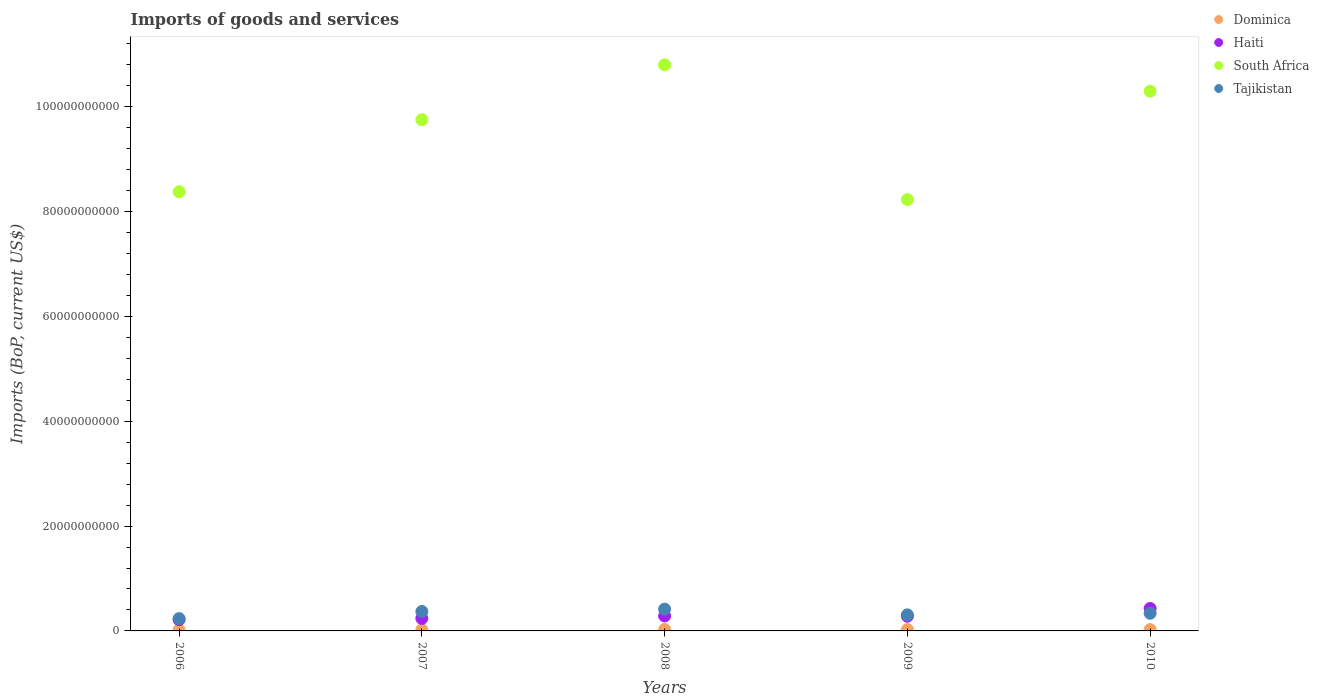What is the amount spent on imports in Haiti in 2006?
Offer a very short reply. 2.14e+09. Across all years, what is the maximum amount spent on imports in South Africa?
Provide a succinct answer. 1.08e+11. Across all years, what is the minimum amount spent on imports in Haiti?
Offer a very short reply. 2.14e+09. In which year was the amount spent on imports in Dominica maximum?
Provide a short and direct response. 2008. In which year was the amount spent on imports in Dominica minimum?
Your answer should be compact. 2006. What is the total amount spent on imports in Tajikistan in the graph?
Your answer should be compact. 1.66e+1. What is the difference between the amount spent on imports in Dominica in 2006 and that in 2009?
Your response must be concise. -6.56e+07. What is the difference between the amount spent on imports in Dominica in 2006 and the amount spent on imports in Haiti in 2007?
Offer a terse response. -2.19e+09. What is the average amount spent on imports in Haiti per year?
Your answer should be very brief. 2.89e+09. In the year 2009, what is the difference between the amount spent on imports in Haiti and amount spent on imports in Tajikistan?
Keep it short and to the point. -2.58e+08. In how many years, is the amount spent on imports in Dominica greater than 28000000000 US$?
Give a very brief answer. 0. What is the ratio of the amount spent on imports in Haiti in 2006 to that in 2007?
Keep it short and to the point. 0.9. Is the amount spent on imports in Dominica in 2006 less than that in 2007?
Your answer should be compact. Yes. What is the difference between the highest and the second highest amount spent on imports in Dominica?
Ensure brevity in your answer.  2.28e+07. What is the difference between the highest and the lowest amount spent on imports in Dominica?
Make the answer very short. 8.85e+07. In how many years, is the amount spent on imports in South Africa greater than the average amount spent on imports in South Africa taken over all years?
Your response must be concise. 3. Is it the case that in every year, the sum of the amount spent on imports in Dominica and amount spent on imports in Haiti  is greater than the sum of amount spent on imports in South Africa and amount spent on imports in Tajikistan?
Give a very brief answer. No. Is it the case that in every year, the sum of the amount spent on imports in Tajikistan and amount spent on imports in Haiti  is greater than the amount spent on imports in Dominica?
Your response must be concise. Yes. Is the amount spent on imports in Dominica strictly less than the amount spent on imports in Haiti over the years?
Offer a terse response. Yes. Does the graph contain any zero values?
Offer a terse response. No. Does the graph contain grids?
Your response must be concise. No. How many legend labels are there?
Make the answer very short. 4. How are the legend labels stacked?
Make the answer very short. Vertical. What is the title of the graph?
Your response must be concise. Imports of goods and services. What is the label or title of the X-axis?
Offer a terse response. Years. What is the label or title of the Y-axis?
Offer a very short reply. Imports (BoP, current US$). What is the Imports (BoP, current US$) in Dominica in 2006?
Make the answer very short. 1.99e+08. What is the Imports (BoP, current US$) in Haiti in 2006?
Give a very brief answer. 2.14e+09. What is the Imports (BoP, current US$) of South Africa in 2006?
Offer a very short reply. 8.38e+1. What is the Imports (BoP, current US$) in Tajikistan in 2006?
Offer a terse response. 2.35e+09. What is the Imports (BoP, current US$) of Dominica in 2007?
Ensure brevity in your answer.  2.36e+08. What is the Imports (BoP, current US$) in Haiti in 2007?
Provide a short and direct response. 2.38e+09. What is the Imports (BoP, current US$) in South Africa in 2007?
Offer a very short reply. 9.75e+1. What is the Imports (BoP, current US$) of Tajikistan in 2007?
Keep it short and to the point. 3.71e+09. What is the Imports (BoP, current US$) in Dominica in 2008?
Your response must be concise. 2.87e+08. What is the Imports (BoP, current US$) of Haiti in 2008?
Provide a succinct answer. 2.85e+09. What is the Imports (BoP, current US$) of South Africa in 2008?
Provide a succinct answer. 1.08e+11. What is the Imports (BoP, current US$) in Tajikistan in 2008?
Give a very brief answer. 4.15e+09. What is the Imports (BoP, current US$) of Dominica in 2009?
Offer a terse response. 2.64e+08. What is the Imports (BoP, current US$) of Haiti in 2009?
Keep it short and to the point. 2.80e+09. What is the Imports (BoP, current US$) in South Africa in 2009?
Your answer should be compact. 8.23e+1. What is the Imports (BoP, current US$) in Tajikistan in 2009?
Offer a very short reply. 3.06e+09. What is the Imports (BoP, current US$) in Dominica in 2010?
Ensure brevity in your answer.  2.65e+08. What is the Imports (BoP, current US$) in Haiti in 2010?
Keep it short and to the point. 4.29e+09. What is the Imports (BoP, current US$) of South Africa in 2010?
Ensure brevity in your answer.  1.03e+11. What is the Imports (BoP, current US$) in Tajikistan in 2010?
Your answer should be compact. 3.36e+09. Across all years, what is the maximum Imports (BoP, current US$) of Dominica?
Keep it short and to the point. 2.87e+08. Across all years, what is the maximum Imports (BoP, current US$) of Haiti?
Provide a succinct answer. 4.29e+09. Across all years, what is the maximum Imports (BoP, current US$) of South Africa?
Offer a very short reply. 1.08e+11. Across all years, what is the maximum Imports (BoP, current US$) of Tajikistan?
Keep it short and to the point. 4.15e+09. Across all years, what is the minimum Imports (BoP, current US$) in Dominica?
Provide a short and direct response. 1.99e+08. Across all years, what is the minimum Imports (BoP, current US$) in Haiti?
Your answer should be compact. 2.14e+09. Across all years, what is the minimum Imports (BoP, current US$) in South Africa?
Provide a short and direct response. 8.23e+1. Across all years, what is the minimum Imports (BoP, current US$) of Tajikistan?
Ensure brevity in your answer.  2.35e+09. What is the total Imports (BoP, current US$) in Dominica in the graph?
Your answer should be compact. 1.25e+09. What is the total Imports (BoP, current US$) in Haiti in the graph?
Your answer should be compact. 1.45e+1. What is the total Imports (BoP, current US$) in South Africa in the graph?
Offer a very short reply. 4.74e+11. What is the total Imports (BoP, current US$) of Tajikistan in the graph?
Offer a very short reply. 1.66e+1. What is the difference between the Imports (BoP, current US$) of Dominica in 2006 and that in 2007?
Give a very brief answer. -3.75e+07. What is the difference between the Imports (BoP, current US$) in Haiti in 2006 and that in 2007?
Your answer should be compact. -2.43e+08. What is the difference between the Imports (BoP, current US$) in South Africa in 2006 and that in 2007?
Give a very brief answer. -1.37e+1. What is the difference between the Imports (BoP, current US$) of Tajikistan in 2006 and that in 2007?
Give a very brief answer. -1.36e+09. What is the difference between the Imports (BoP, current US$) of Dominica in 2006 and that in 2008?
Make the answer very short. -8.85e+07. What is the difference between the Imports (BoP, current US$) of Haiti in 2006 and that in 2008?
Your answer should be very brief. -7.12e+08. What is the difference between the Imports (BoP, current US$) of South Africa in 2006 and that in 2008?
Make the answer very short. -2.42e+1. What is the difference between the Imports (BoP, current US$) in Tajikistan in 2006 and that in 2008?
Keep it short and to the point. -1.81e+09. What is the difference between the Imports (BoP, current US$) in Dominica in 2006 and that in 2009?
Give a very brief answer. -6.56e+07. What is the difference between the Imports (BoP, current US$) in Haiti in 2006 and that in 2009?
Make the answer very short. -6.63e+08. What is the difference between the Imports (BoP, current US$) of South Africa in 2006 and that in 2009?
Provide a short and direct response. 1.49e+09. What is the difference between the Imports (BoP, current US$) of Tajikistan in 2006 and that in 2009?
Make the answer very short. -7.13e+08. What is the difference between the Imports (BoP, current US$) of Dominica in 2006 and that in 2010?
Offer a terse response. -6.57e+07. What is the difference between the Imports (BoP, current US$) in Haiti in 2006 and that in 2010?
Your answer should be compact. -2.15e+09. What is the difference between the Imports (BoP, current US$) of South Africa in 2006 and that in 2010?
Offer a terse response. -1.92e+1. What is the difference between the Imports (BoP, current US$) in Tajikistan in 2006 and that in 2010?
Give a very brief answer. -1.02e+09. What is the difference between the Imports (BoP, current US$) of Dominica in 2007 and that in 2008?
Provide a succinct answer. -5.10e+07. What is the difference between the Imports (BoP, current US$) of Haiti in 2007 and that in 2008?
Provide a short and direct response. -4.69e+08. What is the difference between the Imports (BoP, current US$) in South Africa in 2007 and that in 2008?
Provide a succinct answer. -1.05e+1. What is the difference between the Imports (BoP, current US$) of Tajikistan in 2007 and that in 2008?
Your response must be concise. -4.47e+08. What is the difference between the Imports (BoP, current US$) in Dominica in 2007 and that in 2009?
Offer a very short reply. -2.81e+07. What is the difference between the Imports (BoP, current US$) in Haiti in 2007 and that in 2009?
Make the answer very short. -4.20e+08. What is the difference between the Imports (BoP, current US$) of South Africa in 2007 and that in 2009?
Offer a very short reply. 1.52e+1. What is the difference between the Imports (BoP, current US$) of Tajikistan in 2007 and that in 2009?
Provide a short and direct response. 6.45e+08. What is the difference between the Imports (BoP, current US$) of Dominica in 2007 and that in 2010?
Your response must be concise. -2.82e+07. What is the difference between the Imports (BoP, current US$) of Haiti in 2007 and that in 2010?
Offer a very short reply. -1.90e+09. What is the difference between the Imports (BoP, current US$) of South Africa in 2007 and that in 2010?
Offer a very short reply. -5.45e+09. What is the difference between the Imports (BoP, current US$) in Tajikistan in 2007 and that in 2010?
Your answer should be very brief. 3.43e+08. What is the difference between the Imports (BoP, current US$) in Dominica in 2008 and that in 2009?
Provide a short and direct response. 2.29e+07. What is the difference between the Imports (BoP, current US$) in Haiti in 2008 and that in 2009?
Give a very brief answer. 4.96e+07. What is the difference between the Imports (BoP, current US$) in South Africa in 2008 and that in 2009?
Offer a very short reply. 2.57e+1. What is the difference between the Imports (BoP, current US$) in Tajikistan in 2008 and that in 2009?
Your answer should be compact. 1.09e+09. What is the difference between the Imports (BoP, current US$) of Dominica in 2008 and that in 2010?
Offer a terse response. 2.28e+07. What is the difference between the Imports (BoP, current US$) in Haiti in 2008 and that in 2010?
Offer a very short reply. -1.43e+09. What is the difference between the Imports (BoP, current US$) in South Africa in 2008 and that in 2010?
Give a very brief answer. 5.02e+09. What is the difference between the Imports (BoP, current US$) of Tajikistan in 2008 and that in 2010?
Give a very brief answer. 7.90e+08. What is the difference between the Imports (BoP, current US$) of Dominica in 2009 and that in 2010?
Your answer should be very brief. -5.28e+04. What is the difference between the Imports (BoP, current US$) in Haiti in 2009 and that in 2010?
Your response must be concise. -1.48e+09. What is the difference between the Imports (BoP, current US$) in South Africa in 2009 and that in 2010?
Provide a succinct answer. -2.07e+1. What is the difference between the Imports (BoP, current US$) in Tajikistan in 2009 and that in 2010?
Your answer should be very brief. -3.02e+08. What is the difference between the Imports (BoP, current US$) in Dominica in 2006 and the Imports (BoP, current US$) in Haiti in 2007?
Offer a terse response. -2.19e+09. What is the difference between the Imports (BoP, current US$) in Dominica in 2006 and the Imports (BoP, current US$) in South Africa in 2007?
Provide a succinct answer. -9.73e+1. What is the difference between the Imports (BoP, current US$) of Dominica in 2006 and the Imports (BoP, current US$) of Tajikistan in 2007?
Make the answer very short. -3.51e+09. What is the difference between the Imports (BoP, current US$) in Haiti in 2006 and the Imports (BoP, current US$) in South Africa in 2007?
Your answer should be very brief. -9.54e+1. What is the difference between the Imports (BoP, current US$) of Haiti in 2006 and the Imports (BoP, current US$) of Tajikistan in 2007?
Keep it short and to the point. -1.57e+09. What is the difference between the Imports (BoP, current US$) of South Africa in 2006 and the Imports (BoP, current US$) of Tajikistan in 2007?
Your response must be concise. 8.01e+1. What is the difference between the Imports (BoP, current US$) of Dominica in 2006 and the Imports (BoP, current US$) of Haiti in 2008?
Offer a very short reply. -2.65e+09. What is the difference between the Imports (BoP, current US$) in Dominica in 2006 and the Imports (BoP, current US$) in South Africa in 2008?
Give a very brief answer. -1.08e+11. What is the difference between the Imports (BoP, current US$) in Dominica in 2006 and the Imports (BoP, current US$) in Tajikistan in 2008?
Your answer should be very brief. -3.96e+09. What is the difference between the Imports (BoP, current US$) of Haiti in 2006 and the Imports (BoP, current US$) of South Africa in 2008?
Ensure brevity in your answer.  -1.06e+11. What is the difference between the Imports (BoP, current US$) in Haiti in 2006 and the Imports (BoP, current US$) in Tajikistan in 2008?
Ensure brevity in your answer.  -2.01e+09. What is the difference between the Imports (BoP, current US$) of South Africa in 2006 and the Imports (BoP, current US$) of Tajikistan in 2008?
Provide a short and direct response. 7.96e+1. What is the difference between the Imports (BoP, current US$) in Dominica in 2006 and the Imports (BoP, current US$) in Haiti in 2009?
Make the answer very short. -2.61e+09. What is the difference between the Imports (BoP, current US$) in Dominica in 2006 and the Imports (BoP, current US$) in South Africa in 2009?
Make the answer very short. -8.21e+1. What is the difference between the Imports (BoP, current US$) in Dominica in 2006 and the Imports (BoP, current US$) in Tajikistan in 2009?
Keep it short and to the point. -2.86e+09. What is the difference between the Imports (BoP, current US$) of Haiti in 2006 and the Imports (BoP, current US$) of South Africa in 2009?
Ensure brevity in your answer.  -8.01e+1. What is the difference between the Imports (BoP, current US$) of Haiti in 2006 and the Imports (BoP, current US$) of Tajikistan in 2009?
Your answer should be compact. -9.21e+08. What is the difference between the Imports (BoP, current US$) in South Africa in 2006 and the Imports (BoP, current US$) in Tajikistan in 2009?
Offer a very short reply. 8.07e+1. What is the difference between the Imports (BoP, current US$) in Dominica in 2006 and the Imports (BoP, current US$) in Haiti in 2010?
Offer a terse response. -4.09e+09. What is the difference between the Imports (BoP, current US$) in Dominica in 2006 and the Imports (BoP, current US$) in South Africa in 2010?
Your answer should be compact. -1.03e+11. What is the difference between the Imports (BoP, current US$) of Dominica in 2006 and the Imports (BoP, current US$) of Tajikistan in 2010?
Offer a very short reply. -3.17e+09. What is the difference between the Imports (BoP, current US$) of Haiti in 2006 and the Imports (BoP, current US$) of South Africa in 2010?
Offer a terse response. -1.01e+11. What is the difference between the Imports (BoP, current US$) of Haiti in 2006 and the Imports (BoP, current US$) of Tajikistan in 2010?
Offer a very short reply. -1.22e+09. What is the difference between the Imports (BoP, current US$) of South Africa in 2006 and the Imports (BoP, current US$) of Tajikistan in 2010?
Keep it short and to the point. 8.04e+1. What is the difference between the Imports (BoP, current US$) in Dominica in 2007 and the Imports (BoP, current US$) in Haiti in 2008?
Your response must be concise. -2.62e+09. What is the difference between the Imports (BoP, current US$) of Dominica in 2007 and the Imports (BoP, current US$) of South Africa in 2008?
Offer a terse response. -1.08e+11. What is the difference between the Imports (BoP, current US$) in Dominica in 2007 and the Imports (BoP, current US$) in Tajikistan in 2008?
Your response must be concise. -3.92e+09. What is the difference between the Imports (BoP, current US$) of Haiti in 2007 and the Imports (BoP, current US$) of South Africa in 2008?
Provide a succinct answer. -1.06e+11. What is the difference between the Imports (BoP, current US$) in Haiti in 2007 and the Imports (BoP, current US$) in Tajikistan in 2008?
Keep it short and to the point. -1.77e+09. What is the difference between the Imports (BoP, current US$) of South Africa in 2007 and the Imports (BoP, current US$) of Tajikistan in 2008?
Provide a short and direct response. 9.34e+1. What is the difference between the Imports (BoP, current US$) in Dominica in 2007 and the Imports (BoP, current US$) in Haiti in 2009?
Your answer should be very brief. -2.57e+09. What is the difference between the Imports (BoP, current US$) of Dominica in 2007 and the Imports (BoP, current US$) of South Africa in 2009?
Give a very brief answer. -8.20e+1. What is the difference between the Imports (BoP, current US$) in Dominica in 2007 and the Imports (BoP, current US$) in Tajikistan in 2009?
Provide a succinct answer. -2.83e+09. What is the difference between the Imports (BoP, current US$) in Haiti in 2007 and the Imports (BoP, current US$) in South Africa in 2009?
Your answer should be compact. -7.99e+1. What is the difference between the Imports (BoP, current US$) in Haiti in 2007 and the Imports (BoP, current US$) in Tajikistan in 2009?
Offer a terse response. -6.78e+08. What is the difference between the Imports (BoP, current US$) of South Africa in 2007 and the Imports (BoP, current US$) of Tajikistan in 2009?
Offer a very short reply. 9.44e+1. What is the difference between the Imports (BoP, current US$) in Dominica in 2007 and the Imports (BoP, current US$) in Haiti in 2010?
Keep it short and to the point. -4.05e+09. What is the difference between the Imports (BoP, current US$) of Dominica in 2007 and the Imports (BoP, current US$) of South Africa in 2010?
Ensure brevity in your answer.  -1.03e+11. What is the difference between the Imports (BoP, current US$) in Dominica in 2007 and the Imports (BoP, current US$) in Tajikistan in 2010?
Make the answer very short. -3.13e+09. What is the difference between the Imports (BoP, current US$) of Haiti in 2007 and the Imports (BoP, current US$) of South Africa in 2010?
Ensure brevity in your answer.  -1.01e+11. What is the difference between the Imports (BoP, current US$) of Haiti in 2007 and the Imports (BoP, current US$) of Tajikistan in 2010?
Offer a terse response. -9.80e+08. What is the difference between the Imports (BoP, current US$) of South Africa in 2007 and the Imports (BoP, current US$) of Tajikistan in 2010?
Offer a terse response. 9.41e+1. What is the difference between the Imports (BoP, current US$) of Dominica in 2008 and the Imports (BoP, current US$) of Haiti in 2009?
Provide a short and direct response. -2.52e+09. What is the difference between the Imports (BoP, current US$) of Dominica in 2008 and the Imports (BoP, current US$) of South Africa in 2009?
Your answer should be very brief. -8.20e+1. What is the difference between the Imports (BoP, current US$) of Dominica in 2008 and the Imports (BoP, current US$) of Tajikistan in 2009?
Provide a succinct answer. -2.77e+09. What is the difference between the Imports (BoP, current US$) in Haiti in 2008 and the Imports (BoP, current US$) in South Africa in 2009?
Your answer should be compact. -7.94e+1. What is the difference between the Imports (BoP, current US$) of Haiti in 2008 and the Imports (BoP, current US$) of Tajikistan in 2009?
Provide a short and direct response. -2.08e+08. What is the difference between the Imports (BoP, current US$) in South Africa in 2008 and the Imports (BoP, current US$) in Tajikistan in 2009?
Ensure brevity in your answer.  1.05e+11. What is the difference between the Imports (BoP, current US$) in Dominica in 2008 and the Imports (BoP, current US$) in Haiti in 2010?
Provide a succinct answer. -4.00e+09. What is the difference between the Imports (BoP, current US$) in Dominica in 2008 and the Imports (BoP, current US$) in South Africa in 2010?
Make the answer very short. -1.03e+11. What is the difference between the Imports (BoP, current US$) of Dominica in 2008 and the Imports (BoP, current US$) of Tajikistan in 2010?
Provide a succinct answer. -3.08e+09. What is the difference between the Imports (BoP, current US$) in Haiti in 2008 and the Imports (BoP, current US$) in South Africa in 2010?
Keep it short and to the point. -1.00e+11. What is the difference between the Imports (BoP, current US$) of Haiti in 2008 and the Imports (BoP, current US$) of Tajikistan in 2010?
Offer a very short reply. -5.11e+08. What is the difference between the Imports (BoP, current US$) in South Africa in 2008 and the Imports (BoP, current US$) in Tajikistan in 2010?
Offer a terse response. 1.05e+11. What is the difference between the Imports (BoP, current US$) of Dominica in 2009 and the Imports (BoP, current US$) of Haiti in 2010?
Make the answer very short. -4.02e+09. What is the difference between the Imports (BoP, current US$) in Dominica in 2009 and the Imports (BoP, current US$) in South Africa in 2010?
Your answer should be very brief. -1.03e+11. What is the difference between the Imports (BoP, current US$) of Dominica in 2009 and the Imports (BoP, current US$) of Tajikistan in 2010?
Your answer should be very brief. -3.10e+09. What is the difference between the Imports (BoP, current US$) in Haiti in 2009 and the Imports (BoP, current US$) in South Africa in 2010?
Give a very brief answer. -1.00e+11. What is the difference between the Imports (BoP, current US$) of Haiti in 2009 and the Imports (BoP, current US$) of Tajikistan in 2010?
Give a very brief answer. -5.60e+08. What is the difference between the Imports (BoP, current US$) in South Africa in 2009 and the Imports (BoP, current US$) in Tajikistan in 2010?
Ensure brevity in your answer.  7.89e+1. What is the average Imports (BoP, current US$) of Dominica per year?
Your answer should be very brief. 2.50e+08. What is the average Imports (BoP, current US$) in Haiti per year?
Ensure brevity in your answer.  2.89e+09. What is the average Imports (BoP, current US$) of South Africa per year?
Give a very brief answer. 9.49e+1. What is the average Imports (BoP, current US$) in Tajikistan per year?
Your answer should be very brief. 3.33e+09. In the year 2006, what is the difference between the Imports (BoP, current US$) in Dominica and Imports (BoP, current US$) in Haiti?
Keep it short and to the point. -1.94e+09. In the year 2006, what is the difference between the Imports (BoP, current US$) of Dominica and Imports (BoP, current US$) of South Africa?
Your answer should be very brief. -8.36e+1. In the year 2006, what is the difference between the Imports (BoP, current US$) in Dominica and Imports (BoP, current US$) in Tajikistan?
Your answer should be compact. -2.15e+09. In the year 2006, what is the difference between the Imports (BoP, current US$) of Haiti and Imports (BoP, current US$) of South Africa?
Provide a succinct answer. -8.16e+1. In the year 2006, what is the difference between the Imports (BoP, current US$) of Haiti and Imports (BoP, current US$) of Tajikistan?
Offer a terse response. -2.08e+08. In the year 2006, what is the difference between the Imports (BoP, current US$) in South Africa and Imports (BoP, current US$) in Tajikistan?
Your answer should be very brief. 8.14e+1. In the year 2007, what is the difference between the Imports (BoP, current US$) of Dominica and Imports (BoP, current US$) of Haiti?
Give a very brief answer. -2.15e+09. In the year 2007, what is the difference between the Imports (BoP, current US$) in Dominica and Imports (BoP, current US$) in South Africa?
Your response must be concise. -9.73e+1. In the year 2007, what is the difference between the Imports (BoP, current US$) of Dominica and Imports (BoP, current US$) of Tajikistan?
Your answer should be compact. -3.47e+09. In the year 2007, what is the difference between the Imports (BoP, current US$) in Haiti and Imports (BoP, current US$) in South Africa?
Provide a short and direct response. -9.51e+1. In the year 2007, what is the difference between the Imports (BoP, current US$) of Haiti and Imports (BoP, current US$) of Tajikistan?
Offer a terse response. -1.32e+09. In the year 2007, what is the difference between the Imports (BoP, current US$) in South Africa and Imports (BoP, current US$) in Tajikistan?
Keep it short and to the point. 9.38e+1. In the year 2008, what is the difference between the Imports (BoP, current US$) of Dominica and Imports (BoP, current US$) of Haiti?
Give a very brief answer. -2.57e+09. In the year 2008, what is the difference between the Imports (BoP, current US$) of Dominica and Imports (BoP, current US$) of South Africa?
Offer a very short reply. -1.08e+11. In the year 2008, what is the difference between the Imports (BoP, current US$) in Dominica and Imports (BoP, current US$) in Tajikistan?
Give a very brief answer. -3.87e+09. In the year 2008, what is the difference between the Imports (BoP, current US$) in Haiti and Imports (BoP, current US$) in South Africa?
Provide a short and direct response. -1.05e+11. In the year 2008, what is the difference between the Imports (BoP, current US$) in Haiti and Imports (BoP, current US$) in Tajikistan?
Provide a short and direct response. -1.30e+09. In the year 2008, what is the difference between the Imports (BoP, current US$) in South Africa and Imports (BoP, current US$) in Tajikistan?
Make the answer very short. 1.04e+11. In the year 2009, what is the difference between the Imports (BoP, current US$) of Dominica and Imports (BoP, current US$) of Haiti?
Offer a terse response. -2.54e+09. In the year 2009, what is the difference between the Imports (BoP, current US$) of Dominica and Imports (BoP, current US$) of South Africa?
Provide a short and direct response. -8.20e+1. In the year 2009, what is the difference between the Imports (BoP, current US$) of Dominica and Imports (BoP, current US$) of Tajikistan?
Provide a short and direct response. -2.80e+09. In the year 2009, what is the difference between the Imports (BoP, current US$) of Haiti and Imports (BoP, current US$) of South Africa?
Your response must be concise. -7.95e+1. In the year 2009, what is the difference between the Imports (BoP, current US$) in Haiti and Imports (BoP, current US$) in Tajikistan?
Make the answer very short. -2.58e+08. In the year 2009, what is the difference between the Imports (BoP, current US$) of South Africa and Imports (BoP, current US$) of Tajikistan?
Make the answer very short. 7.92e+1. In the year 2010, what is the difference between the Imports (BoP, current US$) in Dominica and Imports (BoP, current US$) in Haiti?
Provide a succinct answer. -4.02e+09. In the year 2010, what is the difference between the Imports (BoP, current US$) in Dominica and Imports (BoP, current US$) in South Africa?
Ensure brevity in your answer.  -1.03e+11. In the year 2010, what is the difference between the Imports (BoP, current US$) in Dominica and Imports (BoP, current US$) in Tajikistan?
Make the answer very short. -3.10e+09. In the year 2010, what is the difference between the Imports (BoP, current US$) of Haiti and Imports (BoP, current US$) of South Africa?
Keep it short and to the point. -9.87e+1. In the year 2010, what is the difference between the Imports (BoP, current US$) of Haiti and Imports (BoP, current US$) of Tajikistan?
Give a very brief answer. 9.23e+08. In the year 2010, what is the difference between the Imports (BoP, current US$) of South Africa and Imports (BoP, current US$) of Tajikistan?
Ensure brevity in your answer.  9.96e+1. What is the ratio of the Imports (BoP, current US$) in Dominica in 2006 to that in 2007?
Offer a very short reply. 0.84. What is the ratio of the Imports (BoP, current US$) in Haiti in 2006 to that in 2007?
Your response must be concise. 0.9. What is the ratio of the Imports (BoP, current US$) in South Africa in 2006 to that in 2007?
Your answer should be compact. 0.86. What is the ratio of the Imports (BoP, current US$) of Tajikistan in 2006 to that in 2007?
Make the answer very short. 0.63. What is the ratio of the Imports (BoP, current US$) of Dominica in 2006 to that in 2008?
Make the answer very short. 0.69. What is the ratio of the Imports (BoP, current US$) of Haiti in 2006 to that in 2008?
Keep it short and to the point. 0.75. What is the ratio of the Imports (BoP, current US$) of South Africa in 2006 to that in 2008?
Offer a terse response. 0.78. What is the ratio of the Imports (BoP, current US$) of Tajikistan in 2006 to that in 2008?
Ensure brevity in your answer.  0.57. What is the ratio of the Imports (BoP, current US$) in Dominica in 2006 to that in 2009?
Keep it short and to the point. 0.75. What is the ratio of the Imports (BoP, current US$) in Haiti in 2006 to that in 2009?
Your answer should be compact. 0.76. What is the ratio of the Imports (BoP, current US$) in South Africa in 2006 to that in 2009?
Make the answer very short. 1.02. What is the ratio of the Imports (BoP, current US$) in Tajikistan in 2006 to that in 2009?
Offer a very short reply. 0.77. What is the ratio of the Imports (BoP, current US$) of Dominica in 2006 to that in 2010?
Ensure brevity in your answer.  0.75. What is the ratio of the Imports (BoP, current US$) in Haiti in 2006 to that in 2010?
Keep it short and to the point. 0.5. What is the ratio of the Imports (BoP, current US$) of South Africa in 2006 to that in 2010?
Make the answer very short. 0.81. What is the ratio of the Imports (BoP, current US$) of Tajikistan in 2006 to that in 2010?
Keep it short and to the point. 0.7. What is the ratio of the Imports (BoP, current US$) in Dominica in 2007 to that in 2008?
Offer a very short reply. 0.82. What is the ratio of the Imports (BoP, current US$) in Haiti in 2007 to that in 2008?
Give a very brief answer. 0.84. What is the ratio of the Imports (BoP, current US$) of South Africa in 2007 to that in 2008?
Make the answer very short. 0.9. What is the ratio of the Imports (BoP, current US$) of Tajikistan in 2007 to that in 2008?
Offer a very short reply. 0.89. What is the ratio of the Imports (BoP, current US$) in Dominica in 2007 to that in 2009?
Offer a very short reply. 0.89. What is the ratio of the Imports (BoP, current US$) of Haiti in 2007 to that in 2009?
Give a very brief answer. 0.85. What is the ratio of the Imports (BoP, current US$) of South Africa in 2007 to that in 2009?
Your response must be concise. 1.19. What is the ratio of the Imports (BoP, current US$) in Tajikistan in 2007 to that in 2009?
Give a very brief answer. 1.21. What is the ratio of the Imports (BoP, current US$) of Dominica in 2007 to that in 2010?
Offer a very short reply. 0.89. What is the ratio of the Imports (BoP, current US$) in Haiti in 2007 to that in 2010?
Ensure brevity in your answer.  0.56. What is the ratio of the Imports (BoP, current US$) of South Africa in 2007 to that in 2010?
Give a very brief answer. 0.95. What is the ratio of the Imports (BoP, current US$) in Tajikistan in 2007 to that in 2010?
Ensure brevity in your answer.  1.1. What is the ratio of the Imports (BoP, current US$) of Dominica in 2008 to that in 2009?
Give a very brief answer. 1.09. What is the ratio of the Imports (BoP, current US$) of Haiti in 2008 to that in 2009?
Your answer should be compact. 1.02. What is the ratio of the Imports (BoP, current US$) of South Africa in 2008 to that in 2009?
Ensure brevity in your answer.  1.31. What is the ratio of the Imports (BoP, current US$) of Tajikistan in 2008 to that in 2009?
Provide a succinct answer. 1.36. What is the ratio of the Imports (BoP, current US$) of Dominica in 2008 to that in 2010?
Offer a very short reply. 1.09. What is the ratio of the Imports (BoP, current US$) of Haiti in 2008 to that in 2010?
Your answer should be compact. 0.67. What is the ratio of the Imports (BoP, current US$) of South Africa in 2008 to that in 2010?
Your response must be concise. 1.05. What is the ratio of the Imports (BoP, current US$) of Tajikistan in 2008 to that in 2010?
Provide a short and direct response. 1.23. What is the ratio of the Imports (BoP, current US$) in Haiti in 2009 to that in 2010?
Offer a very short reply. 0.65. What is the ratio of the Imports (BoP, current US$) of South Africa in 2009 to that in 2010?
Offer a terse response. 0.8. What is the ratio of the Imports (BoP, current US$) in Tajikistan in 2009 to that in 2010?
Provide a succinct answer. 0.91. What is the difference between the highest and the second highest Imports (BoP, current US$) of Dominica?
Provide a succinct answer. 2.28e+07. What is the difference between the highest and the second highest Imports (BoP, current US$) in Haiti?
Provide a succinct answer. 1.43e+09. What is the difference between the highest and the second highest Imports (BoP, current US$) of South Africa?
Ensure brevity in your answer.  5.02e+09. What is the difference between the highest and the second highest Imports (BoP, current US$) in Tajikistan?
Your response must be concise. 4.47e+08. What is the difference between the highest and the lowest Imports (BoP, current US$) of Dominica?
Your response must be concise. 8.85e+07. What is the difference between the highest and the lowest Imports (BoP, current US$) in Haiti?
Provide a succinct answer. 2.15e+09. What is the difference between the highest and the lowest Imports (BoP, current US$) in South Africa?
Provide a succinct answer. 2.57e+1. What is the difference between the highest and the lowest Imports (BoP, current US$) of Tajikistan?
Make the answer very short. 1.81e+09. 